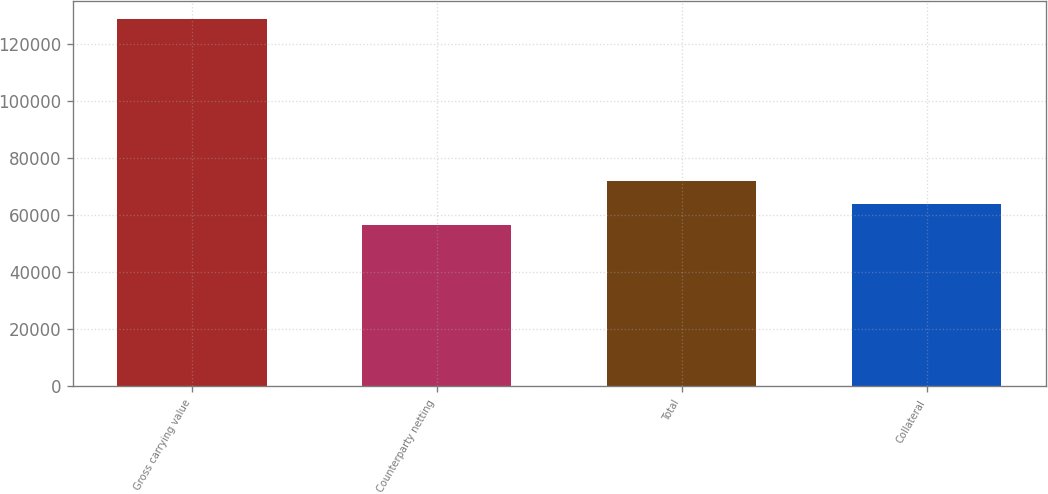Convert chart to OTSL. <chart><loc_0><loc_0><loc_500><loc_500><bar_chart><fcel>Gross carrying value<fcel>Counterparty netting<fcel>Total<fcel>Collateral<nl><fcel>128452<fcel>56636<fcel>71816<fcel>63817.6<nl></chart> 